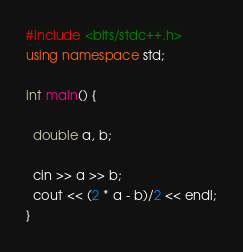<code> <loc_0><loc_0><loc_500><loc_500><_C++_>#include <bits/stdc++.h>
using namespace std;

int main() {
  
  double a, b;
  
  cin >> a >> b;
  cout << (2 * a - b)/2 << endl;
}
</code> 